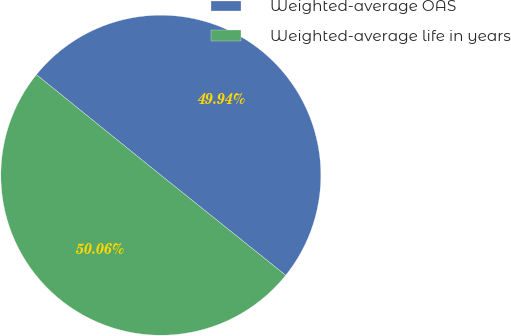Convert chart to OTSL. <chart><loc_0><loc_0><loc_500><loc_500><pie_chart><fcel>Weighted-average OAS<fcel>Weighted-average life in years<nl><fcel>49.94%<fcel>50.06%<nl></chart> 